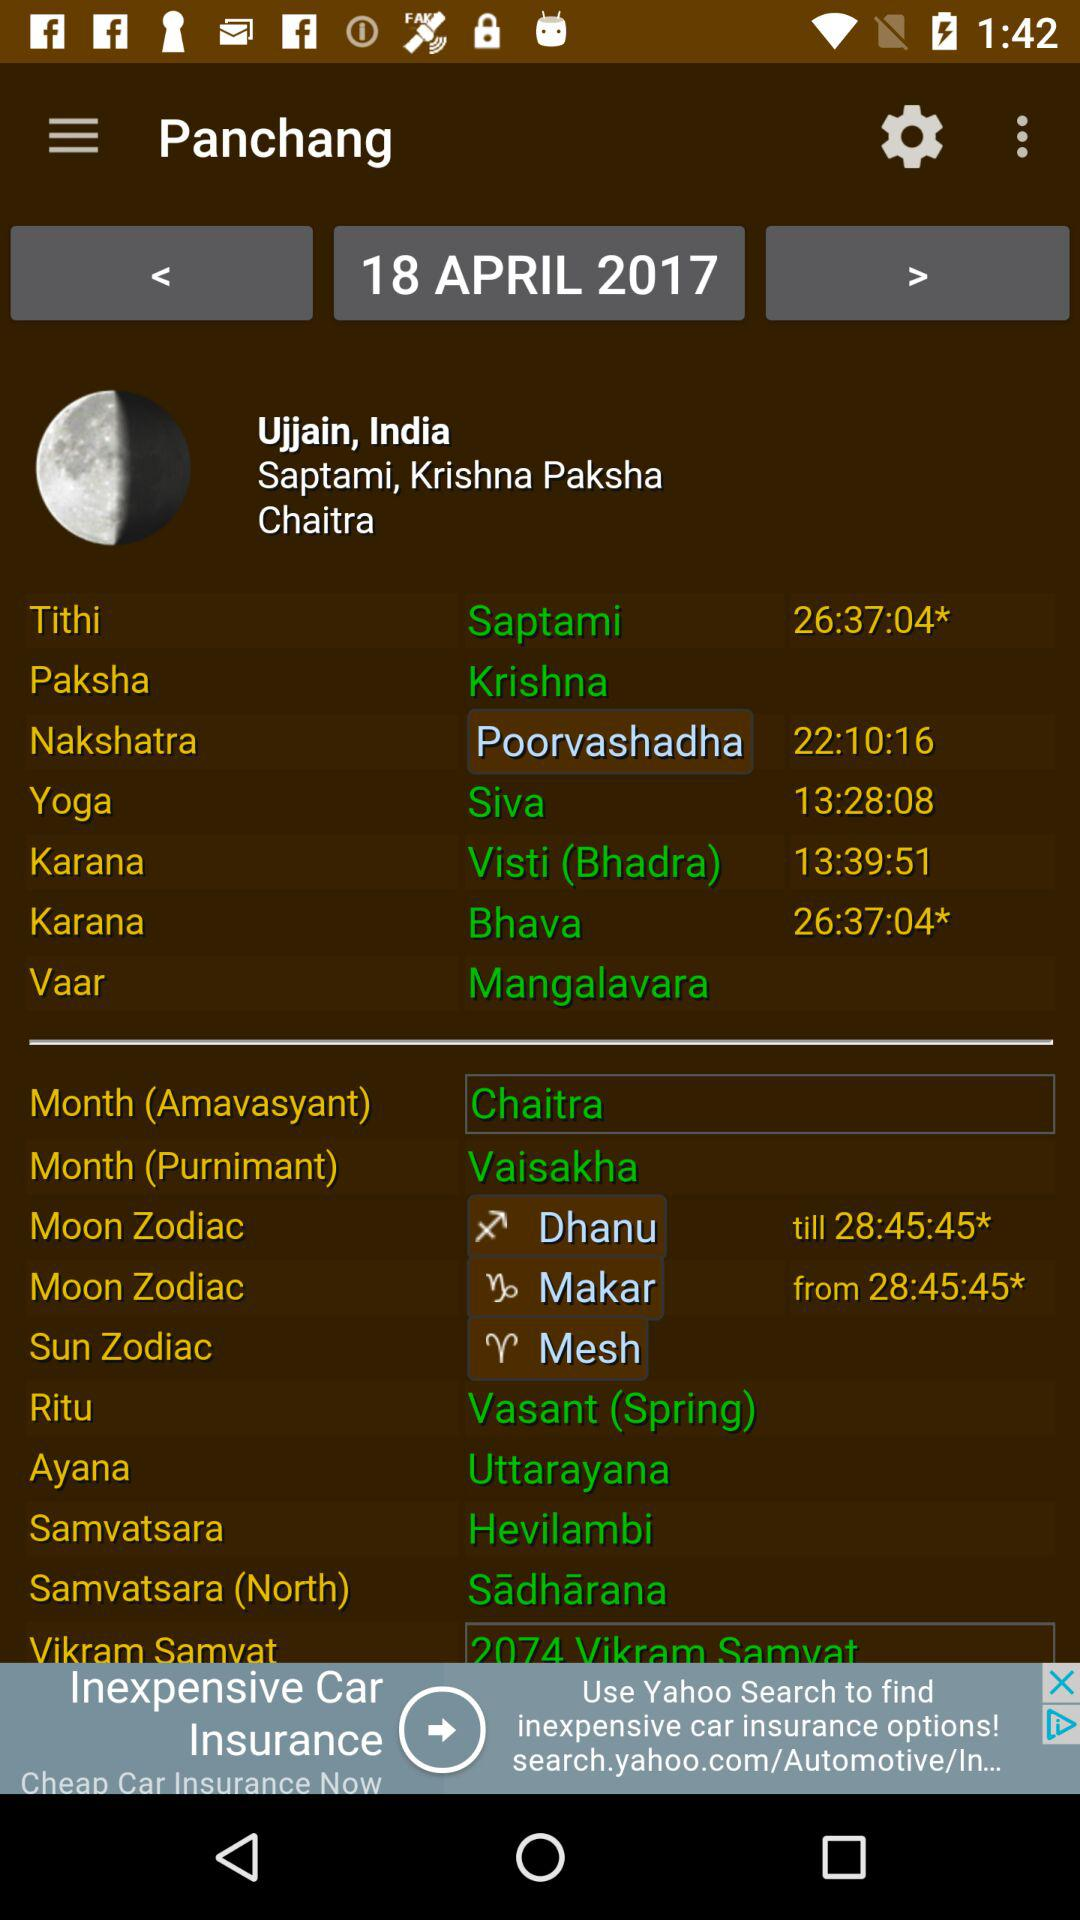What is the tithi? The tithi is saptami. 